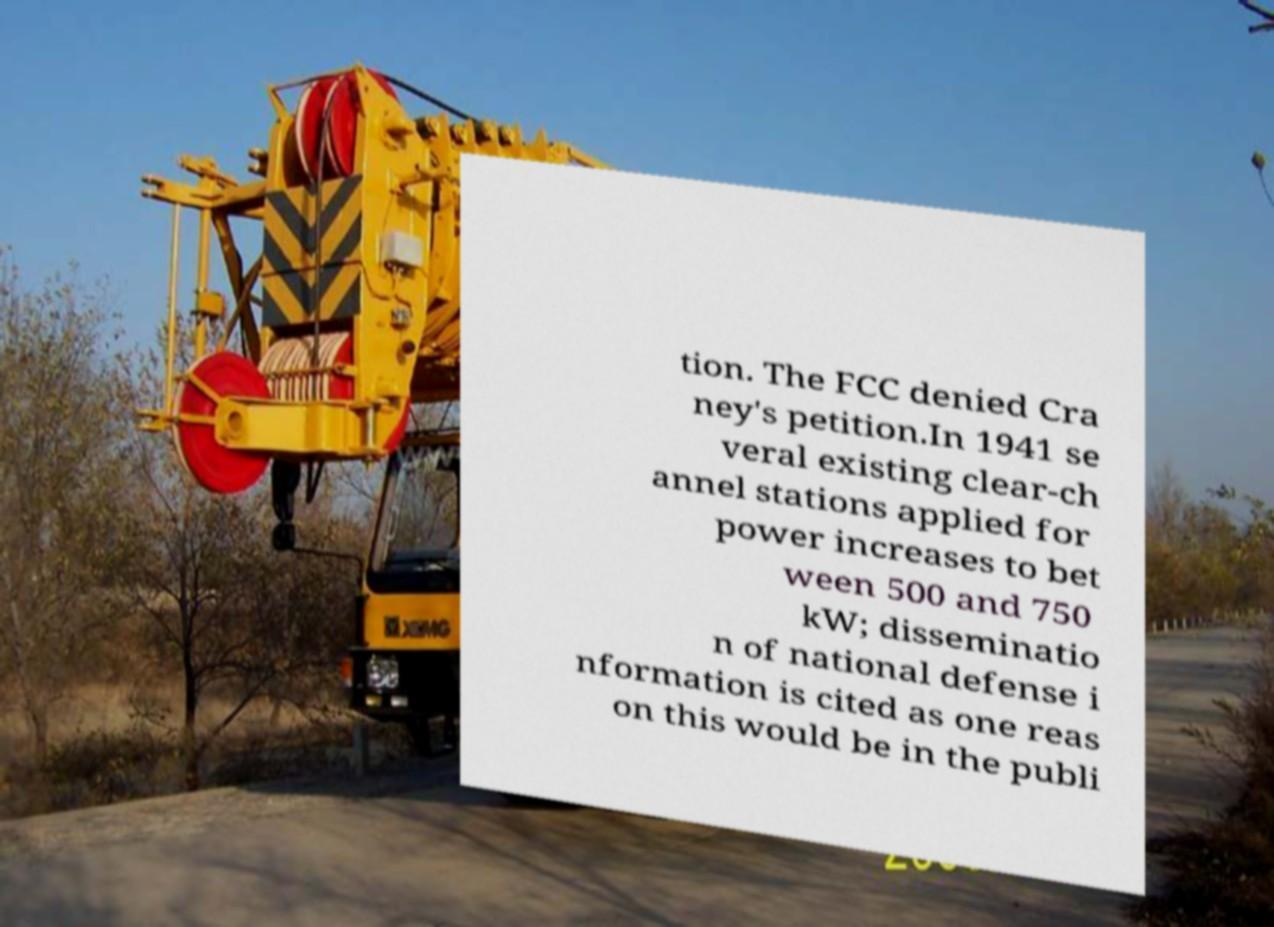Please read and relay the text visible in this image. What does it say? tion. The FCC denied Cra ney's petition.In 1941 se veral existing clear-ch annel stations applied for power increases to bet ween 500 and 750 kW; disseminatio n of national defense i nformation is cited as one reas on this would be in the publi 